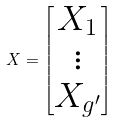Convert formula to latex. <formula><loc_0><loc_0><loc_500><loc_500>X = \begin{bmatrix} X _ { 1 } \\ \vdots \\ X _ { g ^ { \prime } } \end{bmatrix}</formula> 